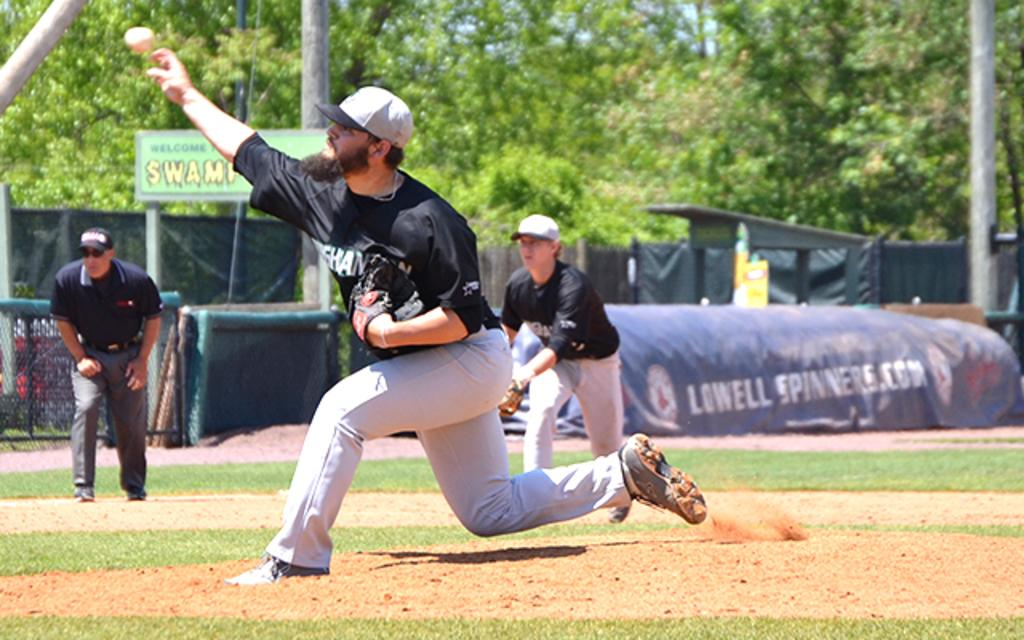<image>
Describe the image concisely. baseball player wearing black and white at the Swamp ballfield 